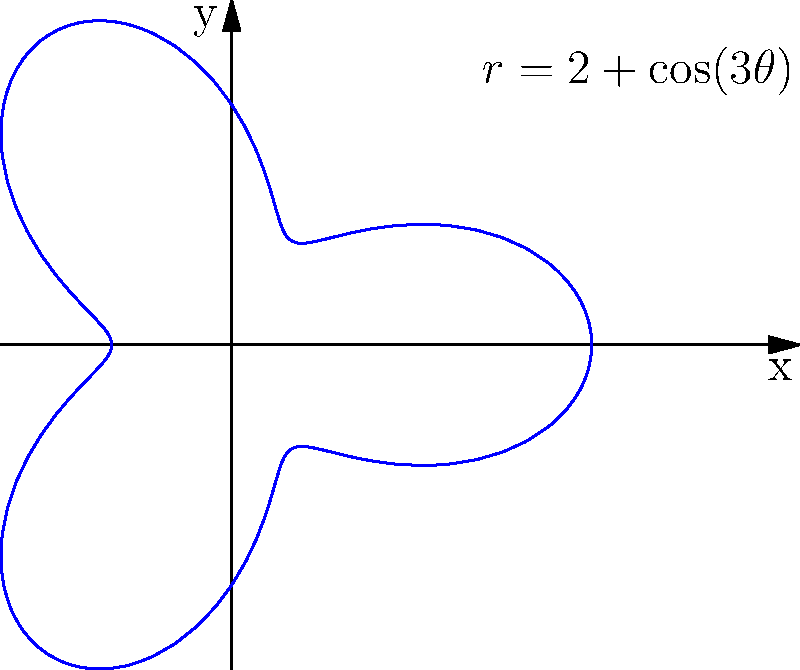You are designing a circular, mandala-like weaving project using a polar equation $r=2+\cos(3\theta)$ (in meters). Calculate the total fabric area needed for this project, rounded to the nearest square meter. To find the area of the region bounded by a polar curve, we use the formula:

$$A = \frac{1}{2} \int_{0}^{2\pi} r^2(\theta) d\theta$$

For our curve $r=2+\cos(3\theta)$, we need to:

1) Square the function:
   $r^2 = (2+\cos(3\theta))^2 = 4 + 4\cos(3\theta) + \cos^2(3\theta)$

2) Integrate from 0 to $2\pi$:
   $$A = \frac{1}{2} \int_{0}^{2\pi} (4 + 4\cos(3\theta) + \cos^2(3\theta)) d\theta$$

3) Integrate each term:
   - $\int_{0}^{2\pi} 4 d\theta = 4\theta \big|_{0}^{2\pi} = 8\pi$
   - $\int_{0}^{2\pi} 4\cos(3\theta) d\theta = \frac{4}{3}\sin(3\theta) \big|_{0}^{2\pi} = 0$
   - $\int_{0}^{2\pi} \cos^2(3\theta) d\theta = \frac{\theta}{2} + \frac{\sin(6\theta)}{12} \big|_{0}^{2\pi} = \pi$

4) Sum up and multiply by $\frac{1}{2}$:
   $$A = \frac{1}{2}(8\pi + 0 + \pi) = \frac{9\pi}{2} \approx 14.14 \text{ square meters}$$

5) Rounding to the nearest square meter:
   14.14 rounds to 14 square meters.
Answer: 14 square meters 